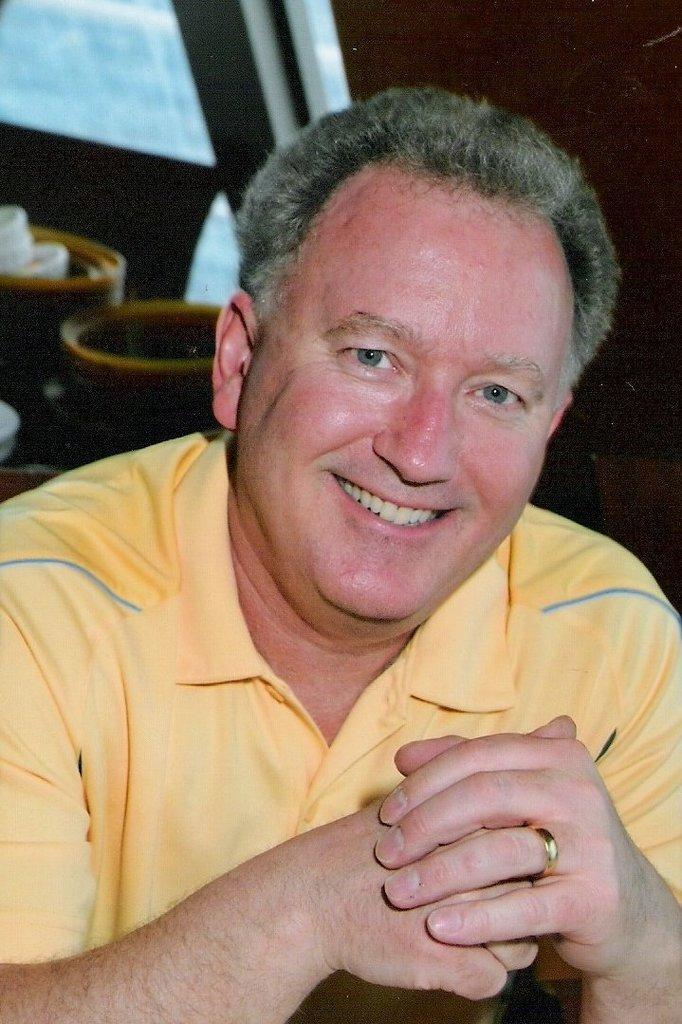Could you give a brief overview of what you see in this image? In this image we can see a man is standing and smiling. In the background the image is not clear to describe but there are objects. 